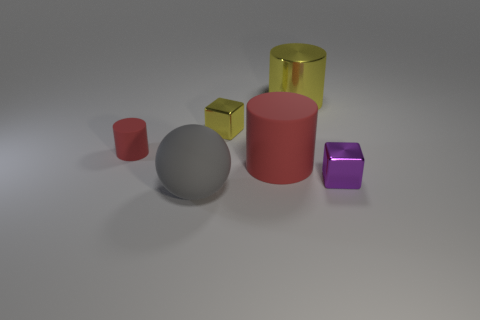What is the small thing to the right of the metallic cylinder made of?
Your answer should be compact. Metal. What number of things are both to the left of the tiny purple cube and behind the large rubber ball?
Provide a short and direct response. 4. There is a metallic block that is on the right side of the large yellow metal object; is its size the same as the matte cylinder to the right of the large rubber sphere?
Ensure brevity in your answer.  No. There is a red cylinder that is to the right of the yellow block; what size is it?
Your response must be concise. Large. What number of things are either small red cylinders in front of the big yellow cylinder or red objects on the right side of the small yellow thing?
Offer a very short reply. 2. Are there any other things that are the same color as the tiny matte cylinder?
Offer a terse response. Yes. Are there an equal number of red rubber objects in front of the purple shiny thing and small red cylinders that are left of the big gray thing?
Your answer should be compact. No. Is the number of matte cylinders left of the purple metallic thing greater than the number of tiny matte objects?
Your answer should be compact. Yes. How many objects are either tiny things left of the large yellow cylinder or large matte balls?
Provide a succinct answer. 3. What number of large cylinders have the same material as the tiny red object?
Your answer should be very brief. 1. 